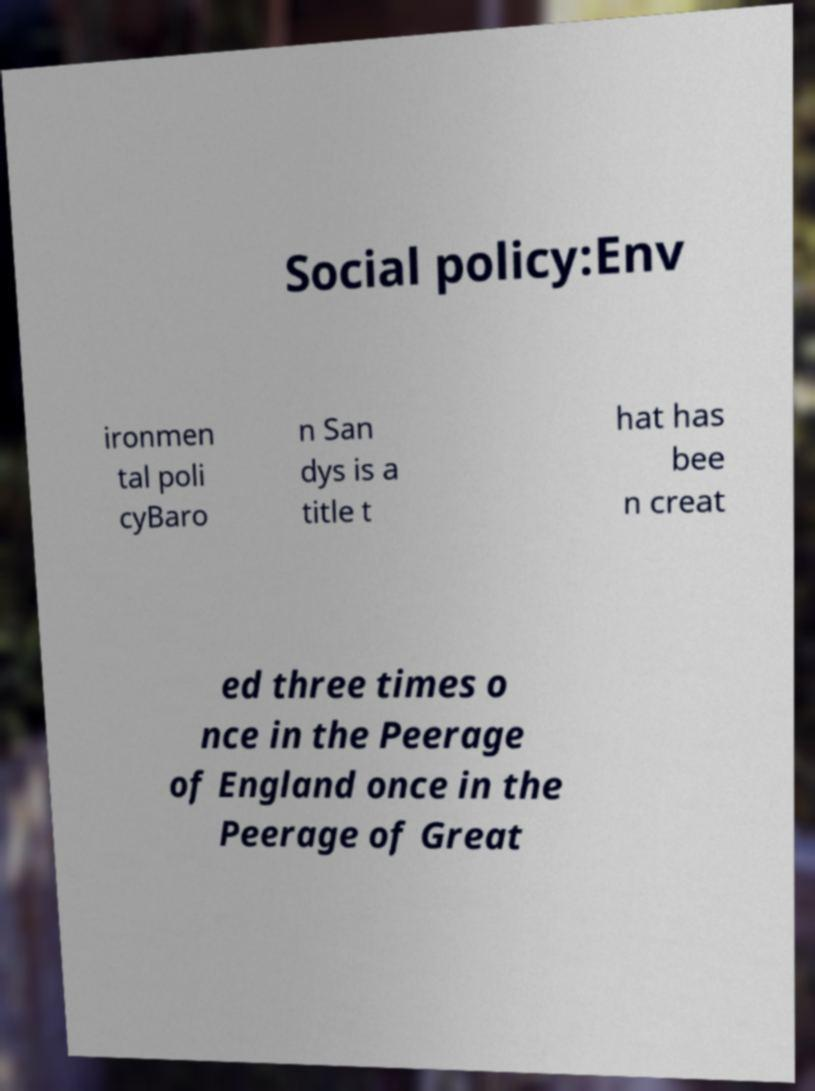Could you extract and type out the text from this image? Social policy:Env ironmen tal poli cyBaro n San dys is a title t hat has bee n creat ed three times o nce in the Peerage of England once in the Peerage of Great 